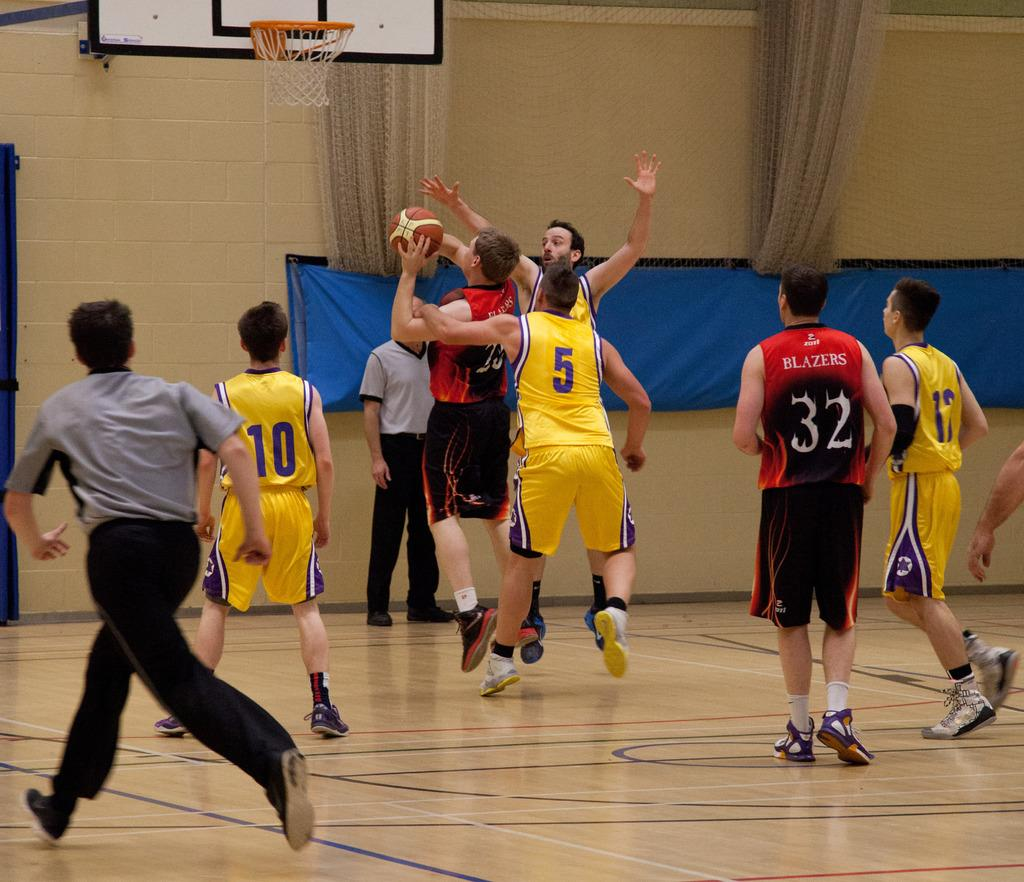What activity are the people in the image engaged in? People are playing basketball in the image. What surface are they playing on? There is a floor visible in the image. What type of window treatment can be seen in the image? There are curtains in the image. What is behind the curtains? There is a wall behind the curtains. What type of crime is being committed in the image? There is no crime being committed in the image; people are playing basketball. What is the surprise element in the scene? There is no surprise element mentioned in the provided facts; the image simply shows people playing basketball on a floor with curtains and a wall in the background. 